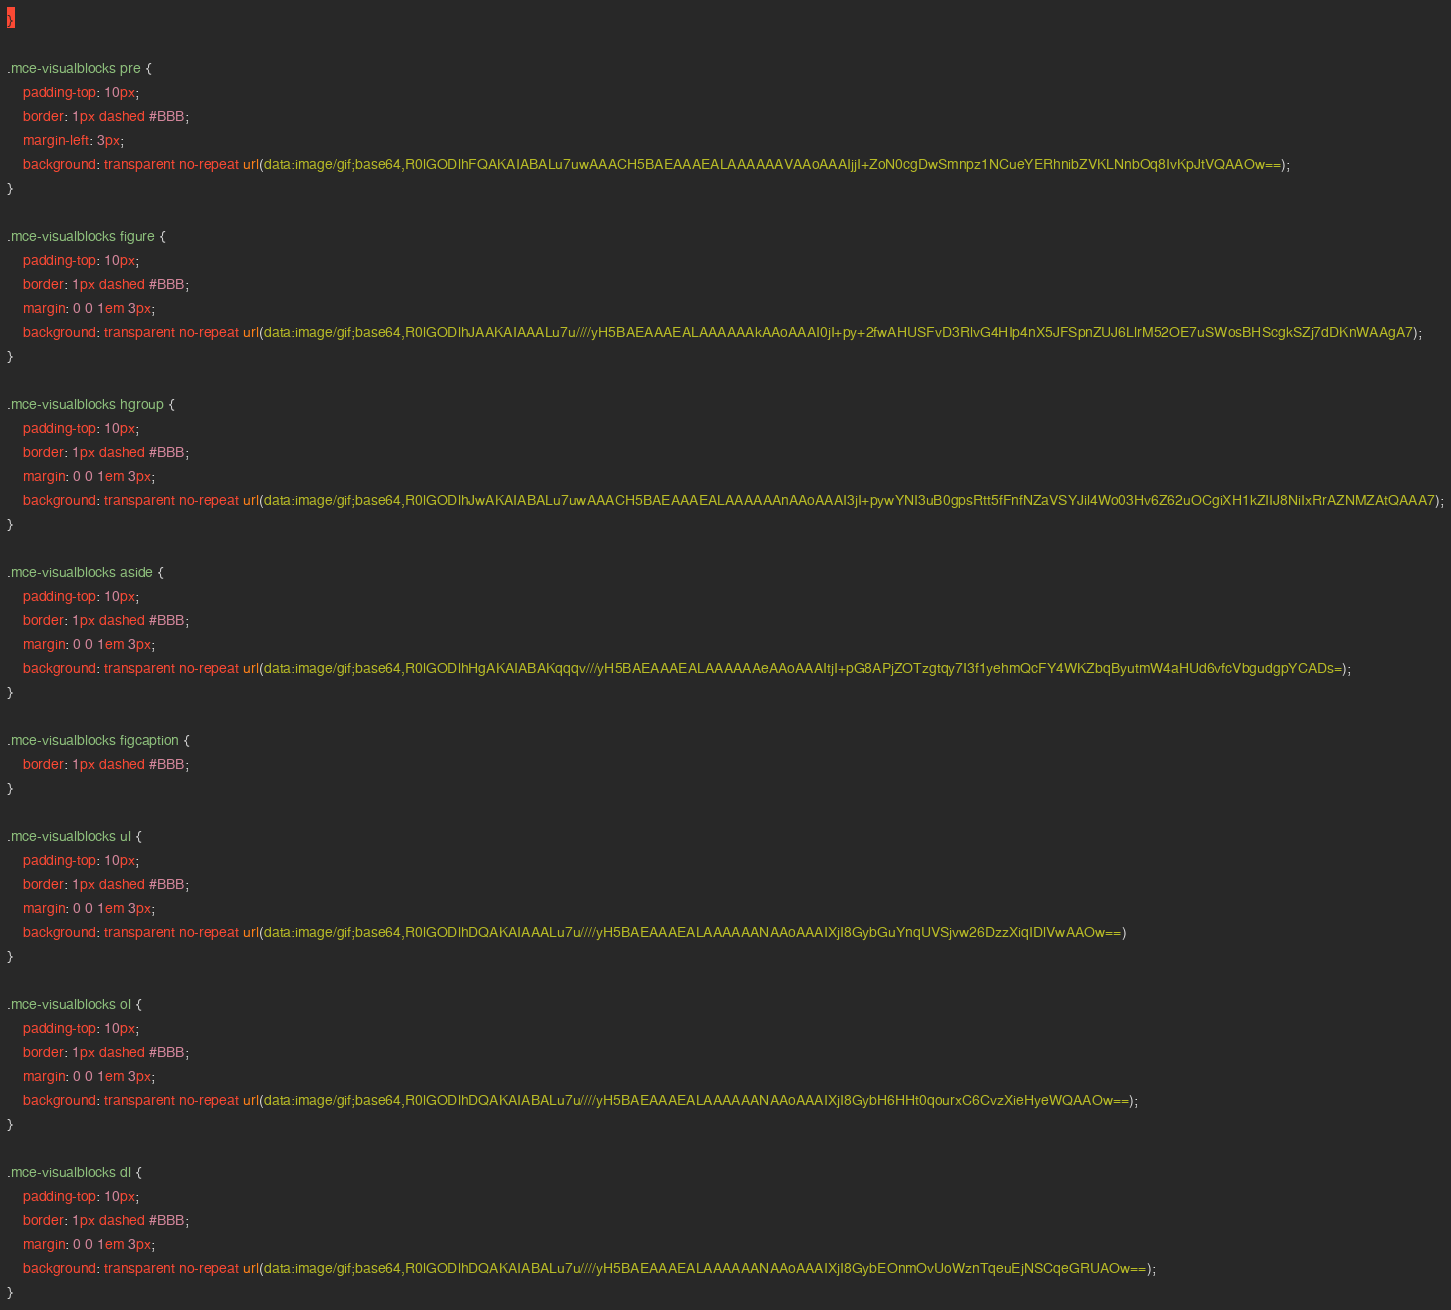Convert code to text. <code><loc_0><loc_0><loc_500><loc_500><_CSS_>}

.mce-visualblocks pre {
	padding-top: 10px;
	border: 1px dashed #BBB;
	margin-left: 3px;
	background: transparent no-repeat url(data:image/gif;base64,R0lGODlhFQAKAIABALu7uwAAACH5BAEAAAEALAAAAAAVAAoAAAIjjI+ZoN0cgDwSmnpz1NCueYERhnibZVKLNnbOq8IvKpJtVQAAOw==);
}

.mce-visualblocks figure {
	padding-top: 10px;
	border: 1px dashed #BBB;
	margin: 0 0 1em 3px;
	background: transparent no-repeat url(data:image/gif;base64,R0lGODlhJAAKAIAAALu7u////yH5BAEAAAEALAAAAAAkAAoAAAI0jI+py+2fwAHUSFvD3RlvG4HIp4nX5JFSpnZUJ6LlrM52OE7uSWosBHScgkSZj7dDKnWAAgA7);
}

.mce-visualblocks hgroup {
	padding-top: 10px;
	border: 1px dashed #BBB;
	margin: 0 0 1em 3px;
	background: transparent no-repeat url(data:image/gif;base64,R0lGODlhJwAKAIABALu7uwAAACH5BAEAAAEALAAAAAAnAAoAAAI3jI+pywYNI3uB0gpsRtt5fFnfNZaVSYJil4Wo03Hv6Z62uOCgiXH1kZIIJ8NiIxRrAZNMZAtQAAA7);
}

.mce-visualblocks aside {
	padding-top: 10px;
	border: 1px dashed #BBB;
	margin: 0 0 1em 3px;
	background: transparent no-repeat url(data:image/gif;base64,R0lGODlhHgAKAIABAKqqqv///yH5BAEAAAEALAAAAAAeAAoAAAItjI+pG8APjZOTzgtqy7I3f1yehmQcFY4WKZbqByutmW4aHUd6vfcVbgudgpYCADs=);
}

.mce-visualblocks figcaption {
	border: 1px dashed #BBB;
}

.mce-visualblocks ul {
	padding-top: 10px;
	border: 1px dashed #BBB;
	margin: 0 0 1em 3px;
	background: transparent no-repeat url(data:image/gif;base64,R0lGODlhDQAKAIAAALu7u////yH5BAEAAAEALAAAAAANAAoAAAIXjI8GybGuYnqUVSjvw26DzzXiqIDlVwAAOw==)
}

.mce-visualblocks ol {
	padding-top: 10px;
	border: 1px dashed #BBB;
	margin: 0 0 1em 3px;
	background: transparent no-repeat url(data:image/gif;base64,R0lGODlhDQAKAIABALu7u////yH5BAEAAAEALAAAAAANAAoAAAIXjI8GybH6HHt0qourxC6CvzXieHyeWQAAOw==);
}

.mce-visualblocks dl {
	padding-top: 10px;
	border: 1px dashed #BBB;
	margin: 0 0 1em 3px;
	background: transparent no-repeat url(data:image/gif;base64,R0lGODlhDQAKAIABALu7u////yH5BAEAAAEALAAAAAANAAoAAAIXjI8GybEOnmOvUoWznTqeuEjNSCqeGRUAOw==);
}
</code> 